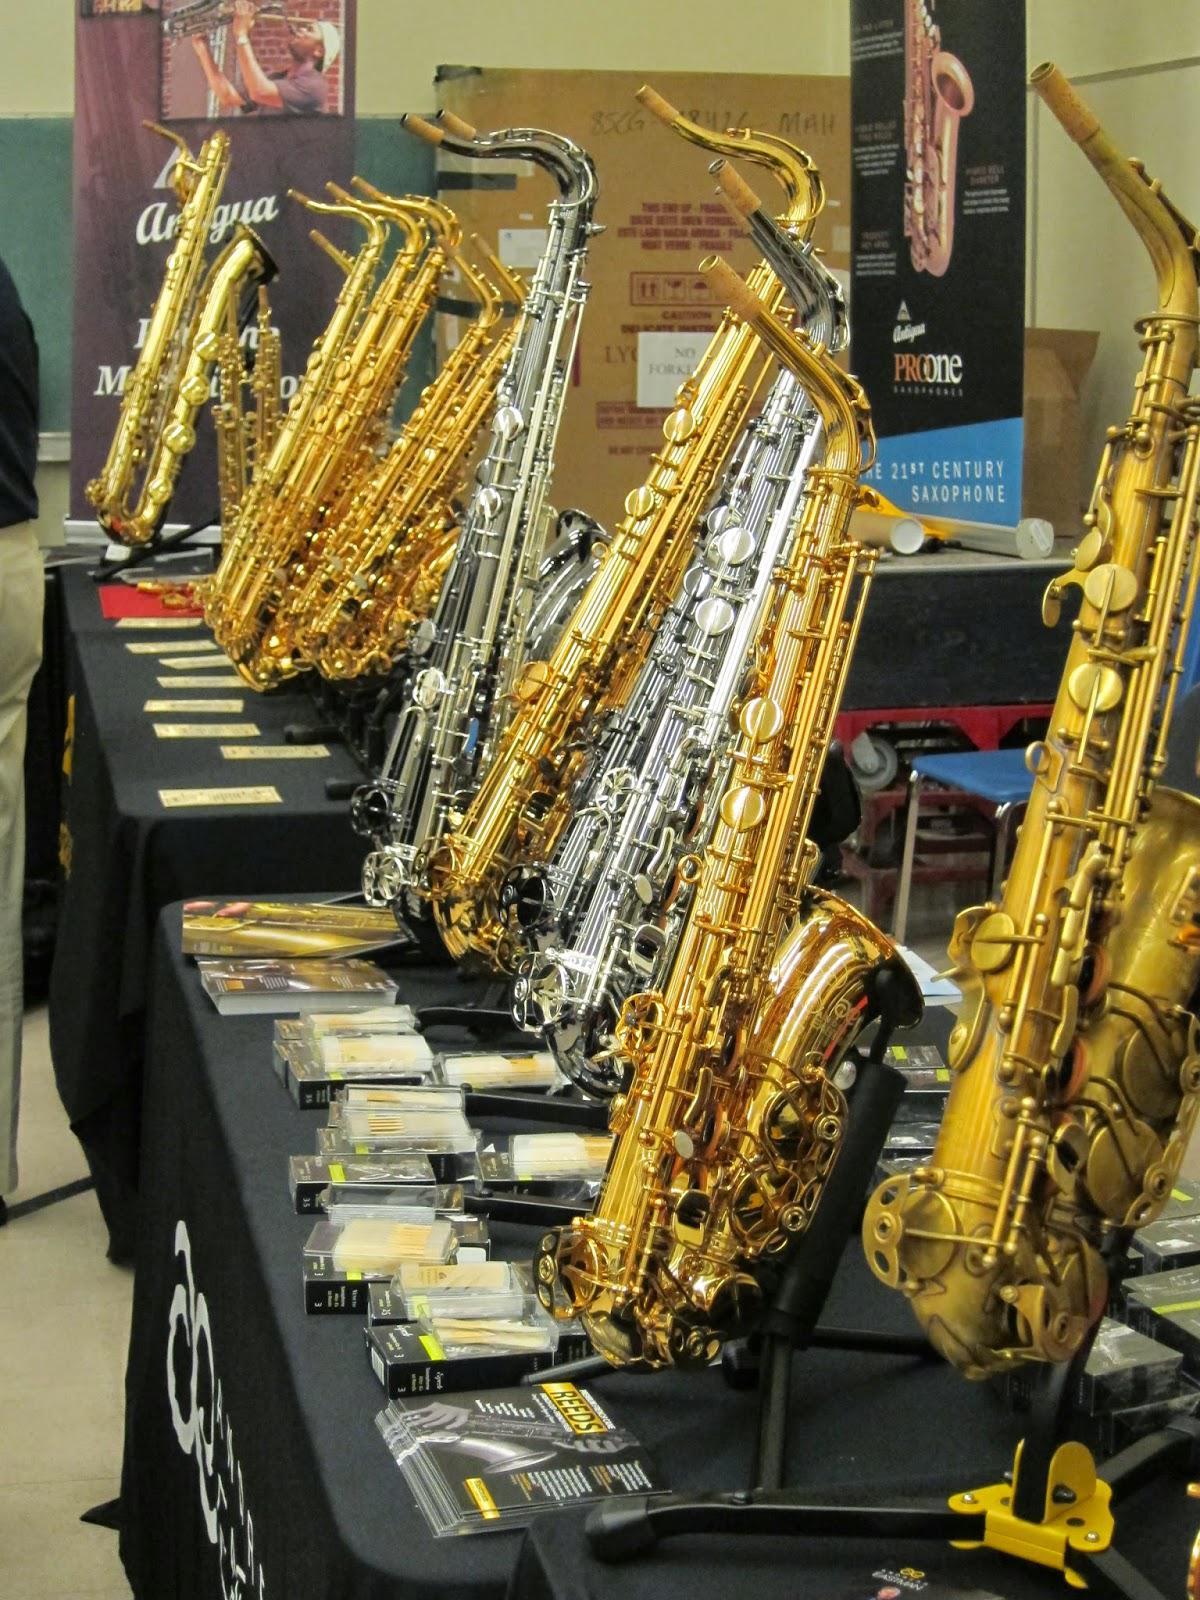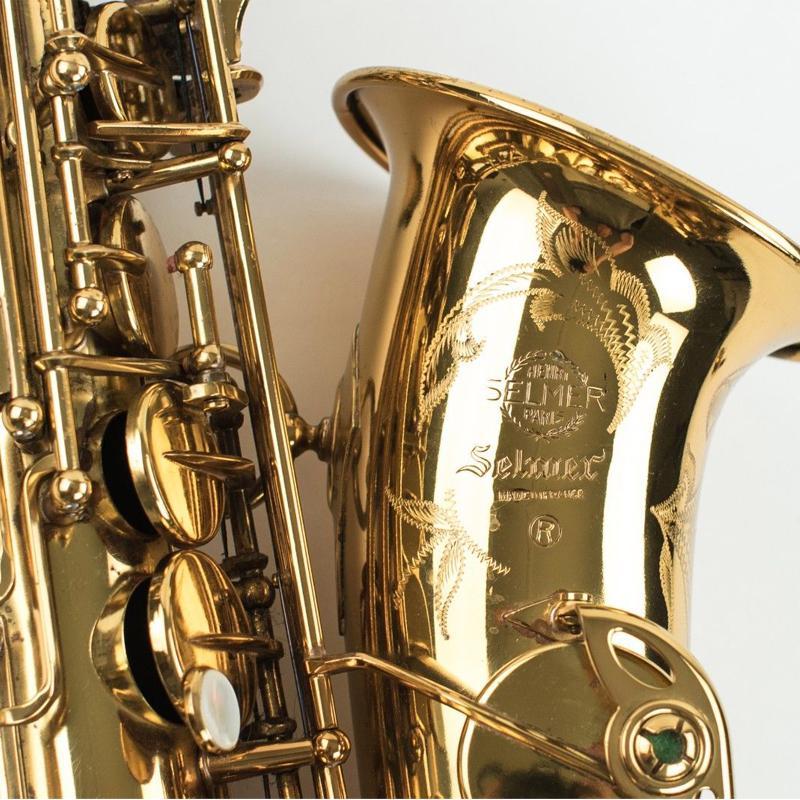The first image is the image on the left, the second image is the image on the right. Considering the images on both sides, is "Right image shows one saxophone and left image shows one row of saxophones." valid? Answer yes or no. Yes. 